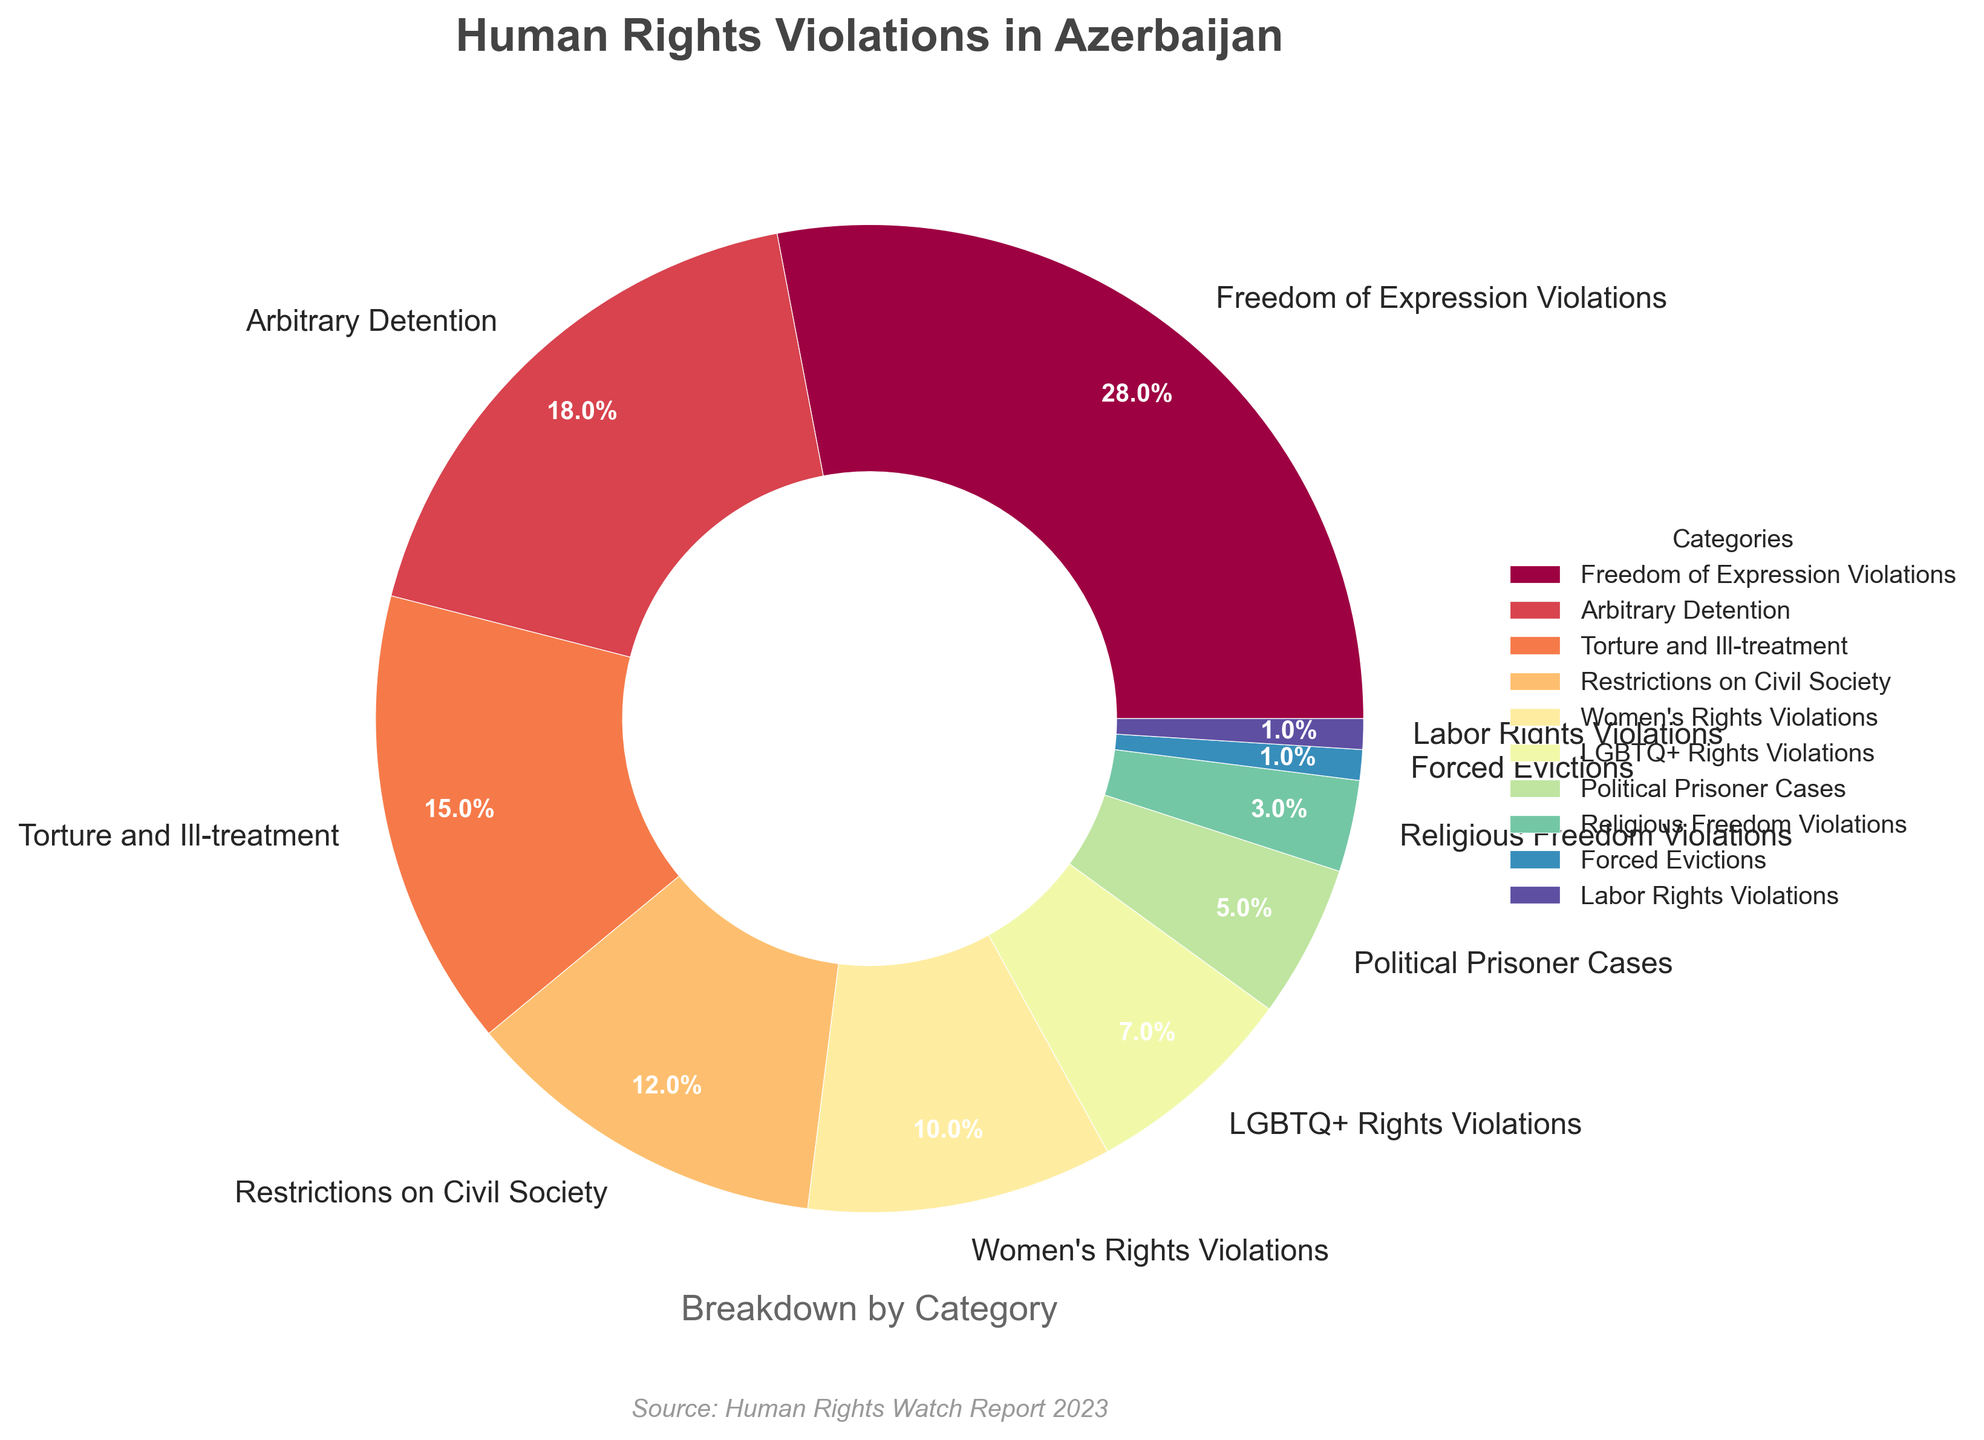Which category has the largest percentage of violations? The largest wedge in the pie chart represents the category "Freedom of Expression Violations" with the highest percentage.
Answer: Freedom of Expression Violations What is the combined percentage of "Women's Rights Violations" and "LGBTQ+ Rights Violations"? The percentage of "Women's Rights Violations" is 10% and the percentage of "LGBTQ+ Rights Violations" is 7%. Adding them together gives 10% + 7% = 17%.
Answer: 17% How much more frequent are "Freedom of Expression Violations" compared to "Forced Evictions"? The percentage for "Freedom of Expression Violations" is 28% and for "Forced Evictions" is 1%. The difference is 28% - 1% = 27%.
Answer: 27% Which categories have violations percentages that are less than 5%? The pie chart shows that "Political Prisoner Cases" (5%), "Religious Freedom Violations" (3%), "Forced Evictions" (1%), and "Labor Rights Violations" (1%) all have percentages less than 5%.
Answer: Political Prisoner Cases, Religious Freedom Violations, Forced Evictions, Labor Rights Violations What percentage of violations does "Arbitrary Detention" account for, and how does it compare to "Torture and Ill-treatment"? "Arbitrary Detention" accounts for 18% of the violations, while "Torture and Ill-treatment" accounts for 15%. The difference is 18% - 15% = 3%.
Answer: 18%, 3% more than "Torture and Ill-treatment" Is the percentage of "Restrictions on Civil Society" higher than the combined percentage of "Forced Evictions" and "Labor Rights Violations"? The percentage of "Restrictions on Civil Society" is 12%. The combined percentage of "Forced Evictions" (1%) and "Labor Rights Violations" (1%) is 1% + 1% = 2%. Since 12% is greater than 2%, "Restrictions on Civil Society" is indeed higher.
Answer: Yes What is the total percentage of all reported human rights violations except the top two categories? The top two categories are "Freedom of Expression Violations" (28%) and "Arbitrary Detention" (18%). The total percentage for the top two categories is 28% + 18% = 46%. Since the total for all categories must be 100%, the remaining percentage is 100% - 46% = 54%.
Answer: 54% Which categories’ wedges have warm colors like red and yellow? By observing the pie chart, the wedges colored in warm tones such as red and yellow typically include some of the larger slices. "Freedom of Expression Violations" (28%) and "Arbitrary Detention" (18%) are in warm colors.
Answer: Freedom of Expression Violations, Arbitrary Detention 